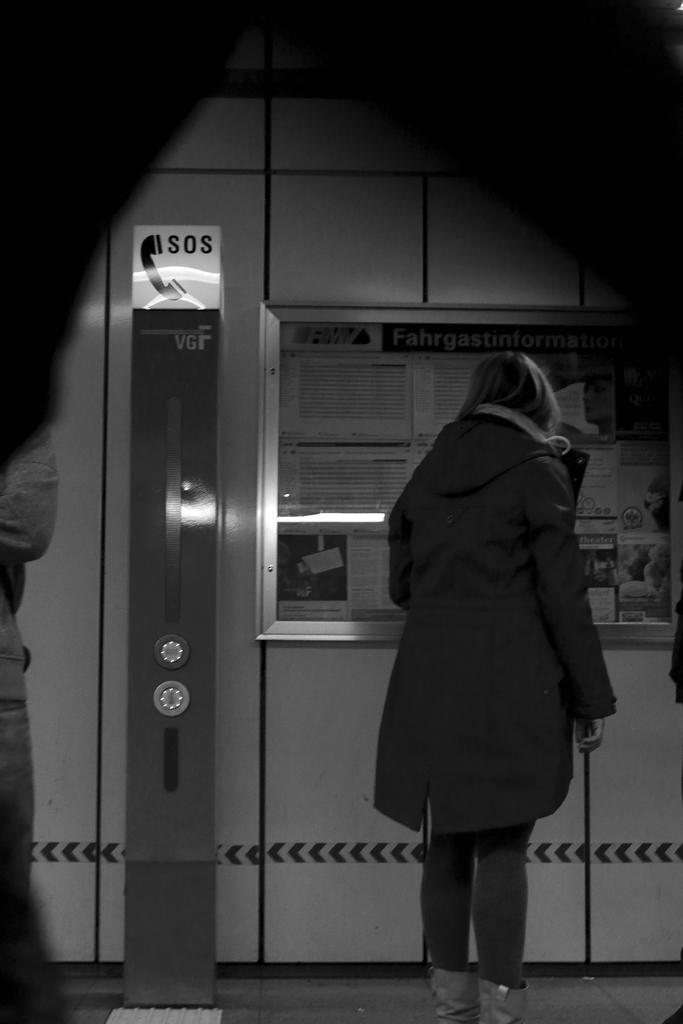<image>
Describe the image concisely. An information booth that says Fahrgastinformation with an sos phone beside of it. 